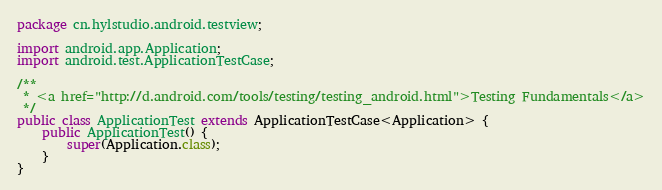<code> <loc_0><loc_0><loc_500><loc_500><_Java_>package cn.hylstudio.android.testview;

import android.app.Application;
import android.test.ApplicationTestCase;

/**
 * <a href="http://d.android.com/tools/testing/testing_android.html">Testing Fundamentals</a>
 */
public class ApplicationTest extends ApplicationTestCase<Application> {
    public ApplicationTest() {
        super(Application.class);
    }
}</code> 